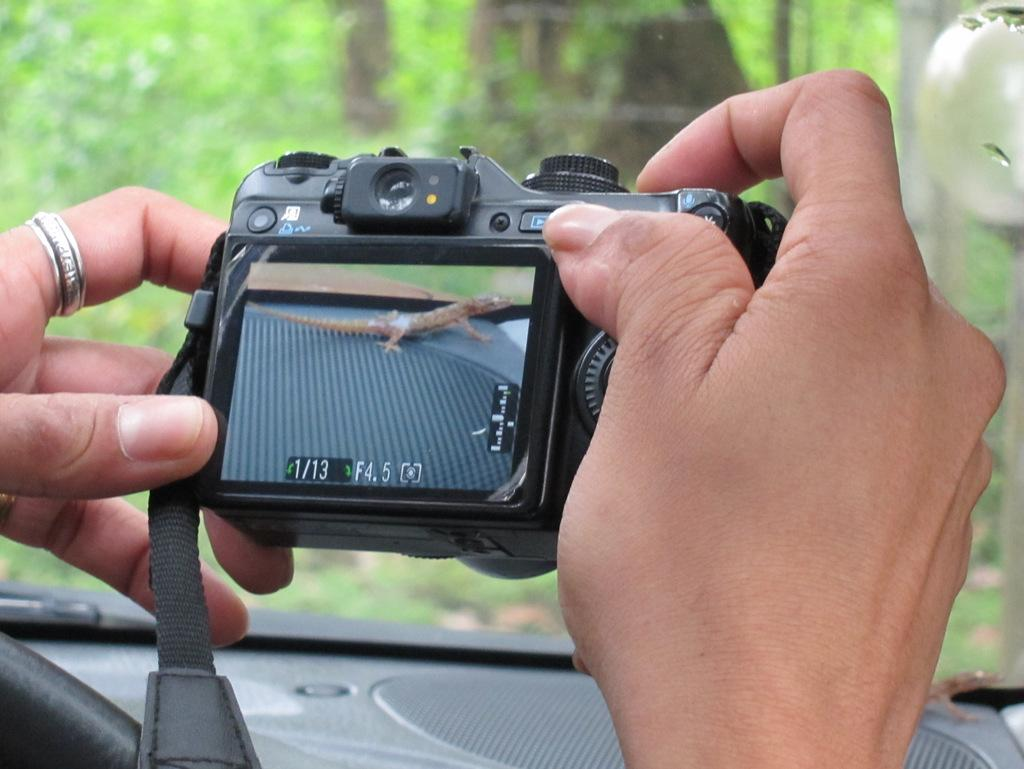<image>
Summarize the visual content of the image. A person is taking a photo of a lizard with a camera set to F4.5 